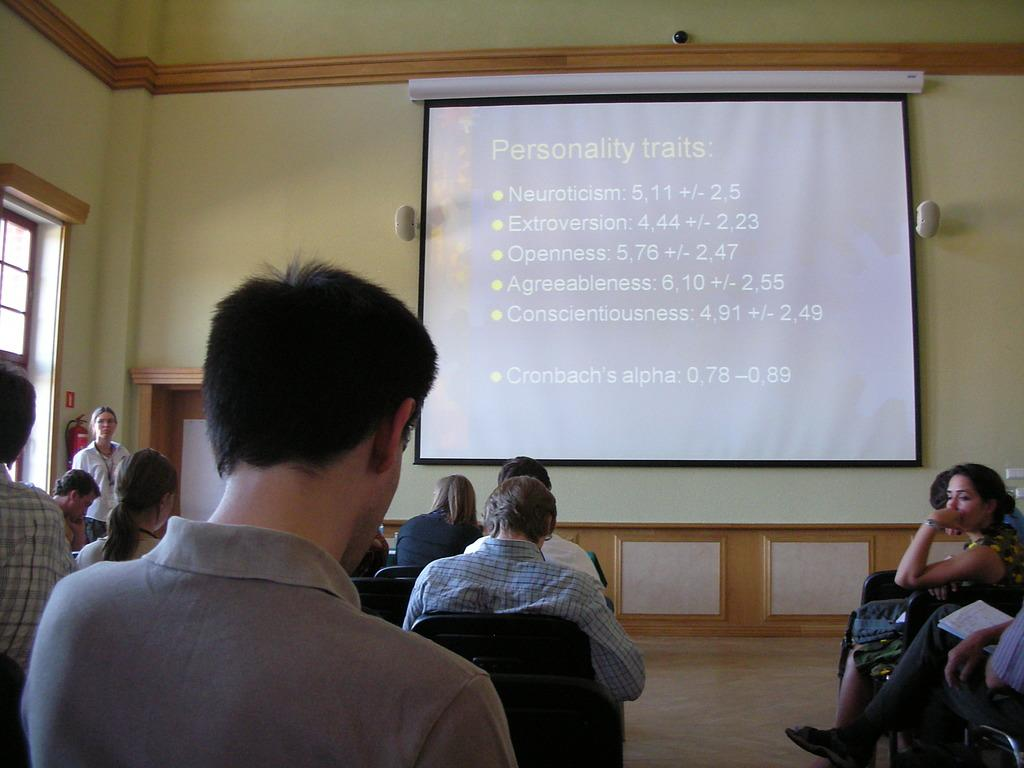What are the people in the image doing? The people in the image are sitting on chairs or the floor. What can be seen in the background of the image? There is a wall, a screen, speakers, a light, and a window in the background. Can you describe the woman in the image? There is a woman standing at the door in the image. What type of songs can be heard coming from the window in the image? There is no indication in the image that songs can be heard coming from the window, as the image does not depict any sounds. 